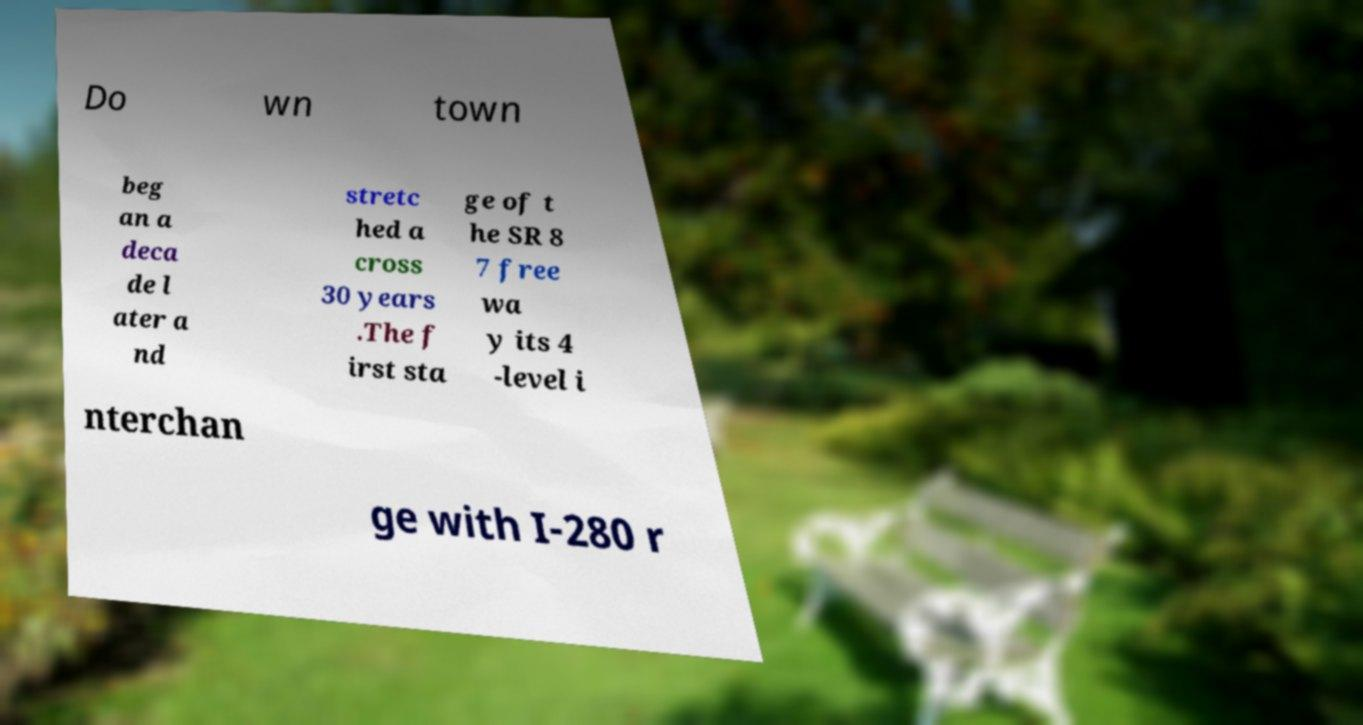Could you assist in decoding the text presented in this image and type it out clearly? Do wn town beg an a deca de l ater a nd stretc hed a cross 30 years .The f irst sta ge of t he SR 8 7 free wa y its 4 -level i nterchan ge with I-280 r 